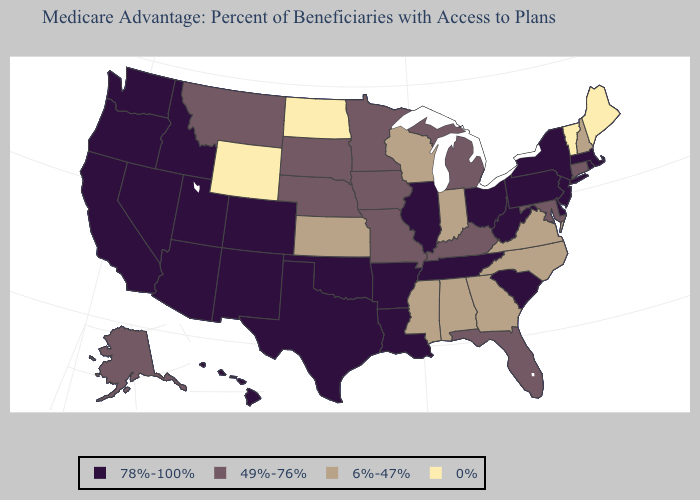What is the highest value in states that border North Dakota?
Quick response, please. 49%-76%. How many symbols are there in the legend?
Concise answer only. 4. Among the states that border Kentucky , which have the lowest value?
Write a very short answer. Indiana, Virginia. Which states have the lowest value in the MidWest?
Concise answer only. North Dakota. Does Oklahoma have a lower value than Connecticut?
Short answer required. No. Name the states that have a value in the range 6%-47%?
Short answer required. Alabama, Georgia, Indiana, Kansas, Mississippi, North Carolina, New Hampshire, Virginia, Wisconsin. Name the states that have a value in the range 0%?
Keep it brief. Maine, North Dakota, Vermont, Wyoming. Among the states that border South Dakota , which have the lowest value?
Short answer required. North Dakota, Wyoming. Which states have the highest value in the USA?
Keep it brief. Arkansas, Arizona, California, Colorado, Delaware, Hawaii, Idaho, Illinois, Louisiana, Massachusetts, New Jersey, New Mexico, Nevada, New York, Ohio, Oklahoma, Oregon, Pennsylvania, Rhode Island, South Carolina, Tennessee, Texas, Utah, Washington, West Virginia. Among the states that border Virginia , does Maryland have the lowest value?
Quick response, please. No. Name the states that have a value in the range 0%?
Keep it brief. Maine, North Dakota, Vermont, Wyoming. What is the value of Nebraska?
Quick response, please. 49%-76%. What is the value of Nevada?
Give a very brief answer. 78%-100%. What is the value of Minnesota?
Concise answer only. 49%-76%. 